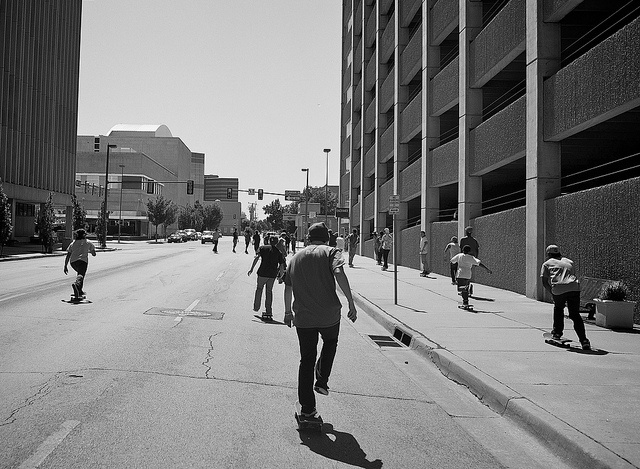Describe the objects in this image and their specific colors. I can see people in black, gray, darkgray, and lightgray tones, people in black, lightgray, gray, and darkgray tones, people in black, gray, darkgray, and lightgray tones, potted plant in black, gray, darkgray, and lightgray tones, and people in black, gray, darkgray, and lightgray tones in this image. 